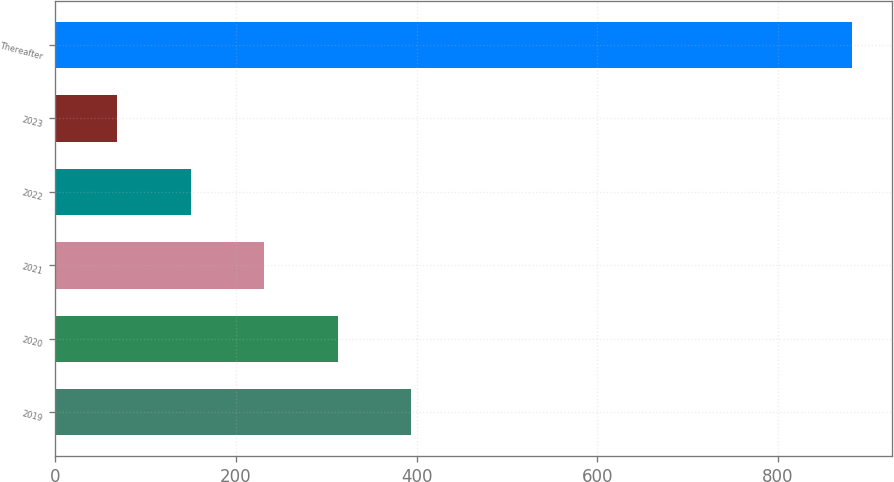<chart> <loc_0><loc_0><loc_500><loc_500><bar_chart><fcel>2019<fcel>2020<fcel>2021<fcel>2022<fcel>2023<fcel>Thereafter<nl><fcel>394.02<fcel>312.69<fcel>231.36<fcel>150.03<fcel>68.7<fcel>882<nl></chart> 